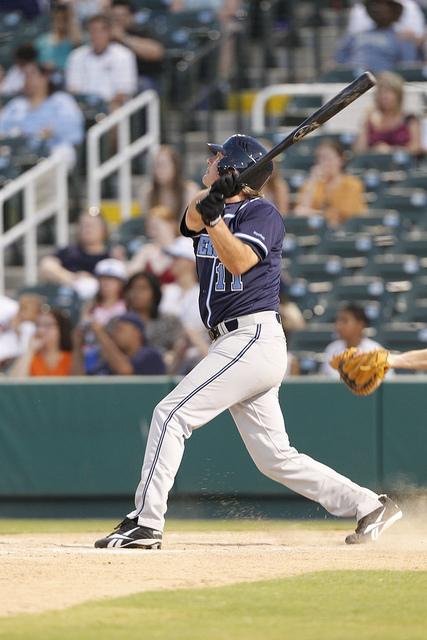Is there a person behind this man?
Keep it brief. Yes. Which foot is furthest forward?
Be succinct. Left. Did he just hit the ball?
Be succinct. Yes. 